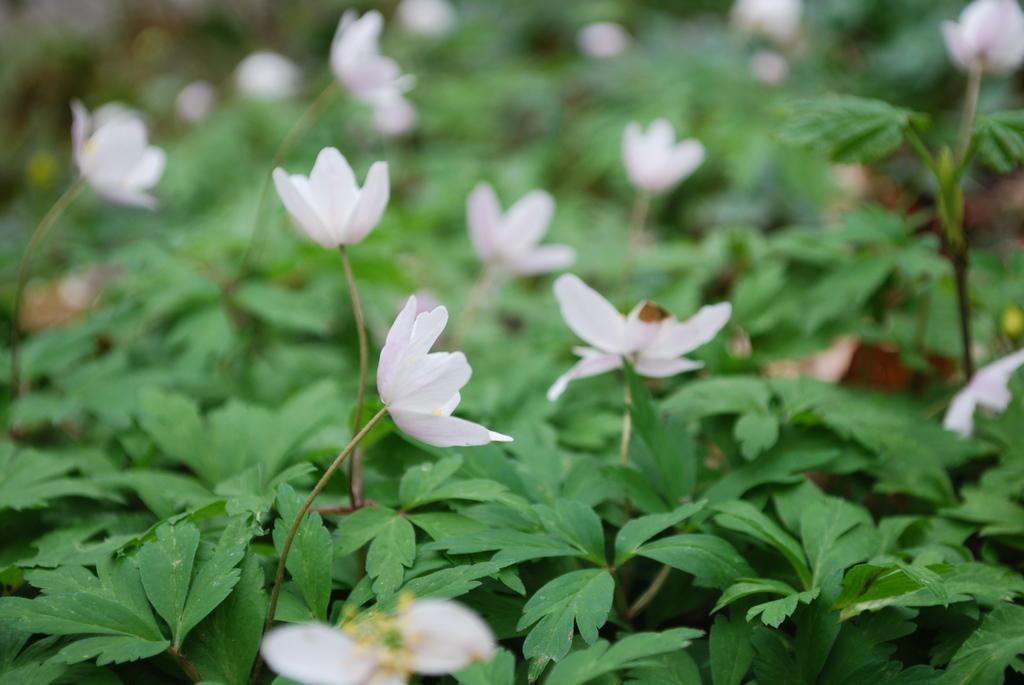Can you describe this image briefly? Here we can see plants with white flowers. 